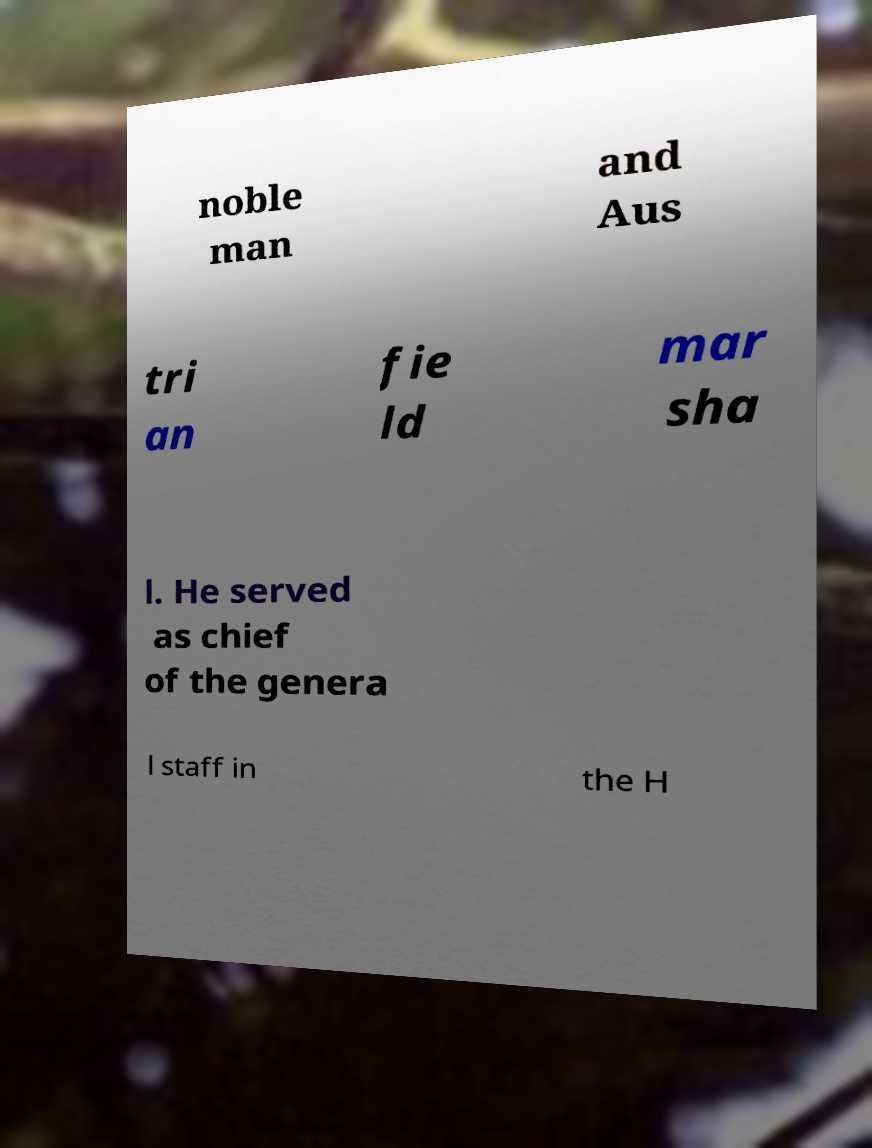Please read and relay the text visible in this image. What does it say? noble man and Aus tri an fie ld mar sha l. He served as chief of the genera l staff in the H 